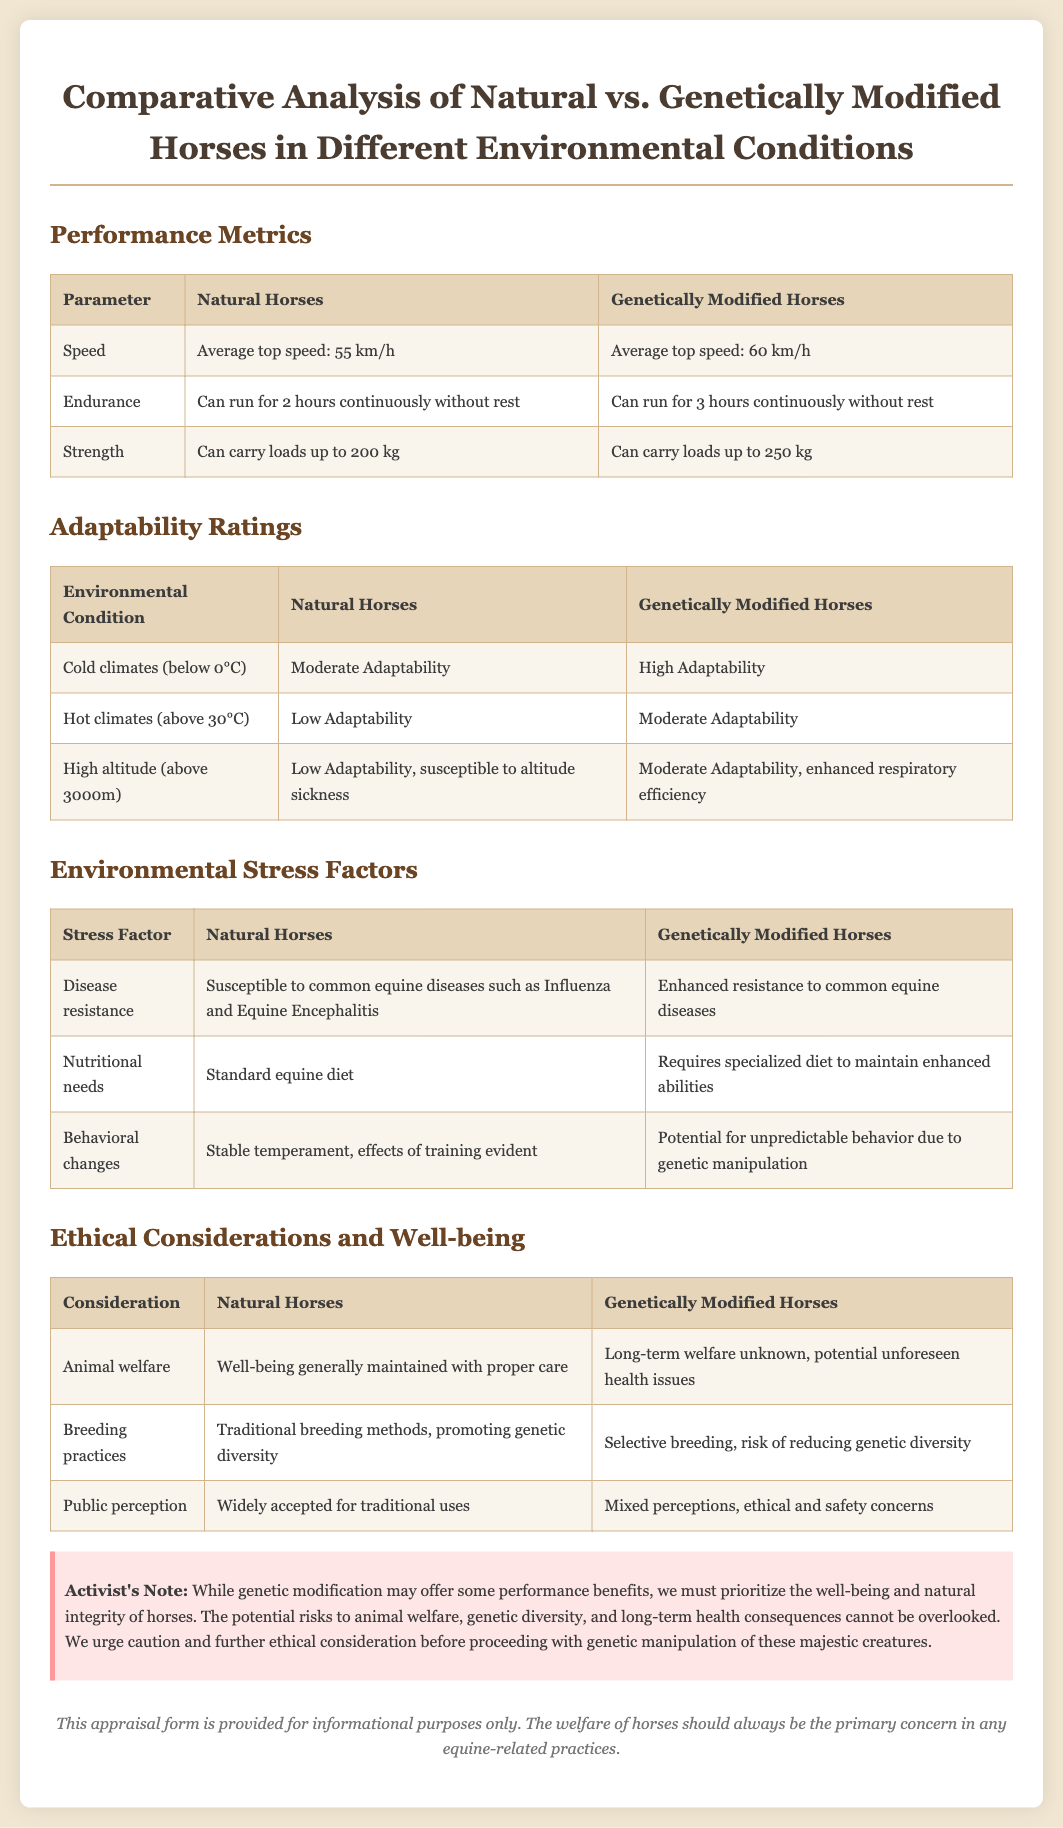what is the average top speed of Natural Horses? The average top speed of Natural Horses is provided in the performance metrics section.
Answer: 55 km/h what is the endurance capacity of Genetically Modified Horses? The endurance capacity of Genetically Modified Horses can be found in the performance metrics section.
Answer: Can run for 3 hours continuously without rest how do Natural Horses adapt to hot climates? Adaptability ratings for Natural Horses in hot climates is detailed in the adaptability ratings section.
Answer: Low Adaptability what is a potential behavioral change in Genetically Modified Horses? The environmental stress factors section mentions behavior in relation to Genetically Modified Horses.
Answer: Potential for unpredictable behavior due to genetic manipulation what is the public perception of Genetically Modified Horses? The public perception is discussed under ethical considerations, focusing on differences between horse types.
Answer: Mixed perceptions, ethical and safety concerns how much weight can Natural Horses carry? The performance metrics section specifies the carrying capacity for Natural Horses.
Answer: Up to 200 kg what is the risk associated with breeding practices for Genetically Modified Horses? The breeding practices are outlined in the ethical considerations section, discussing implications.
Answer: Risk of reducing genetic diversity what is the environmental stress factor regarding disease resistance for Natural Horses? The environmental stress factors table details disease resistance for Natural Horses.
Answer: Susceptible to common equine diseases such as Influenza and Equine Encephalitis what is the warning message highlighted in the document? The warning message is emphasized in a distinct section to address concerns.
Answer: Priority on the well-being and natural integrity of horses 